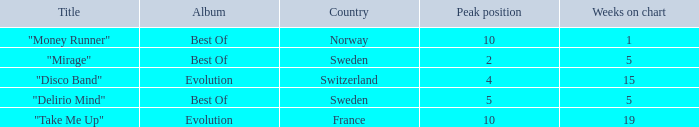What is the most weeks on chart when the peak position is less than 5 and from sweden? 5.0. 